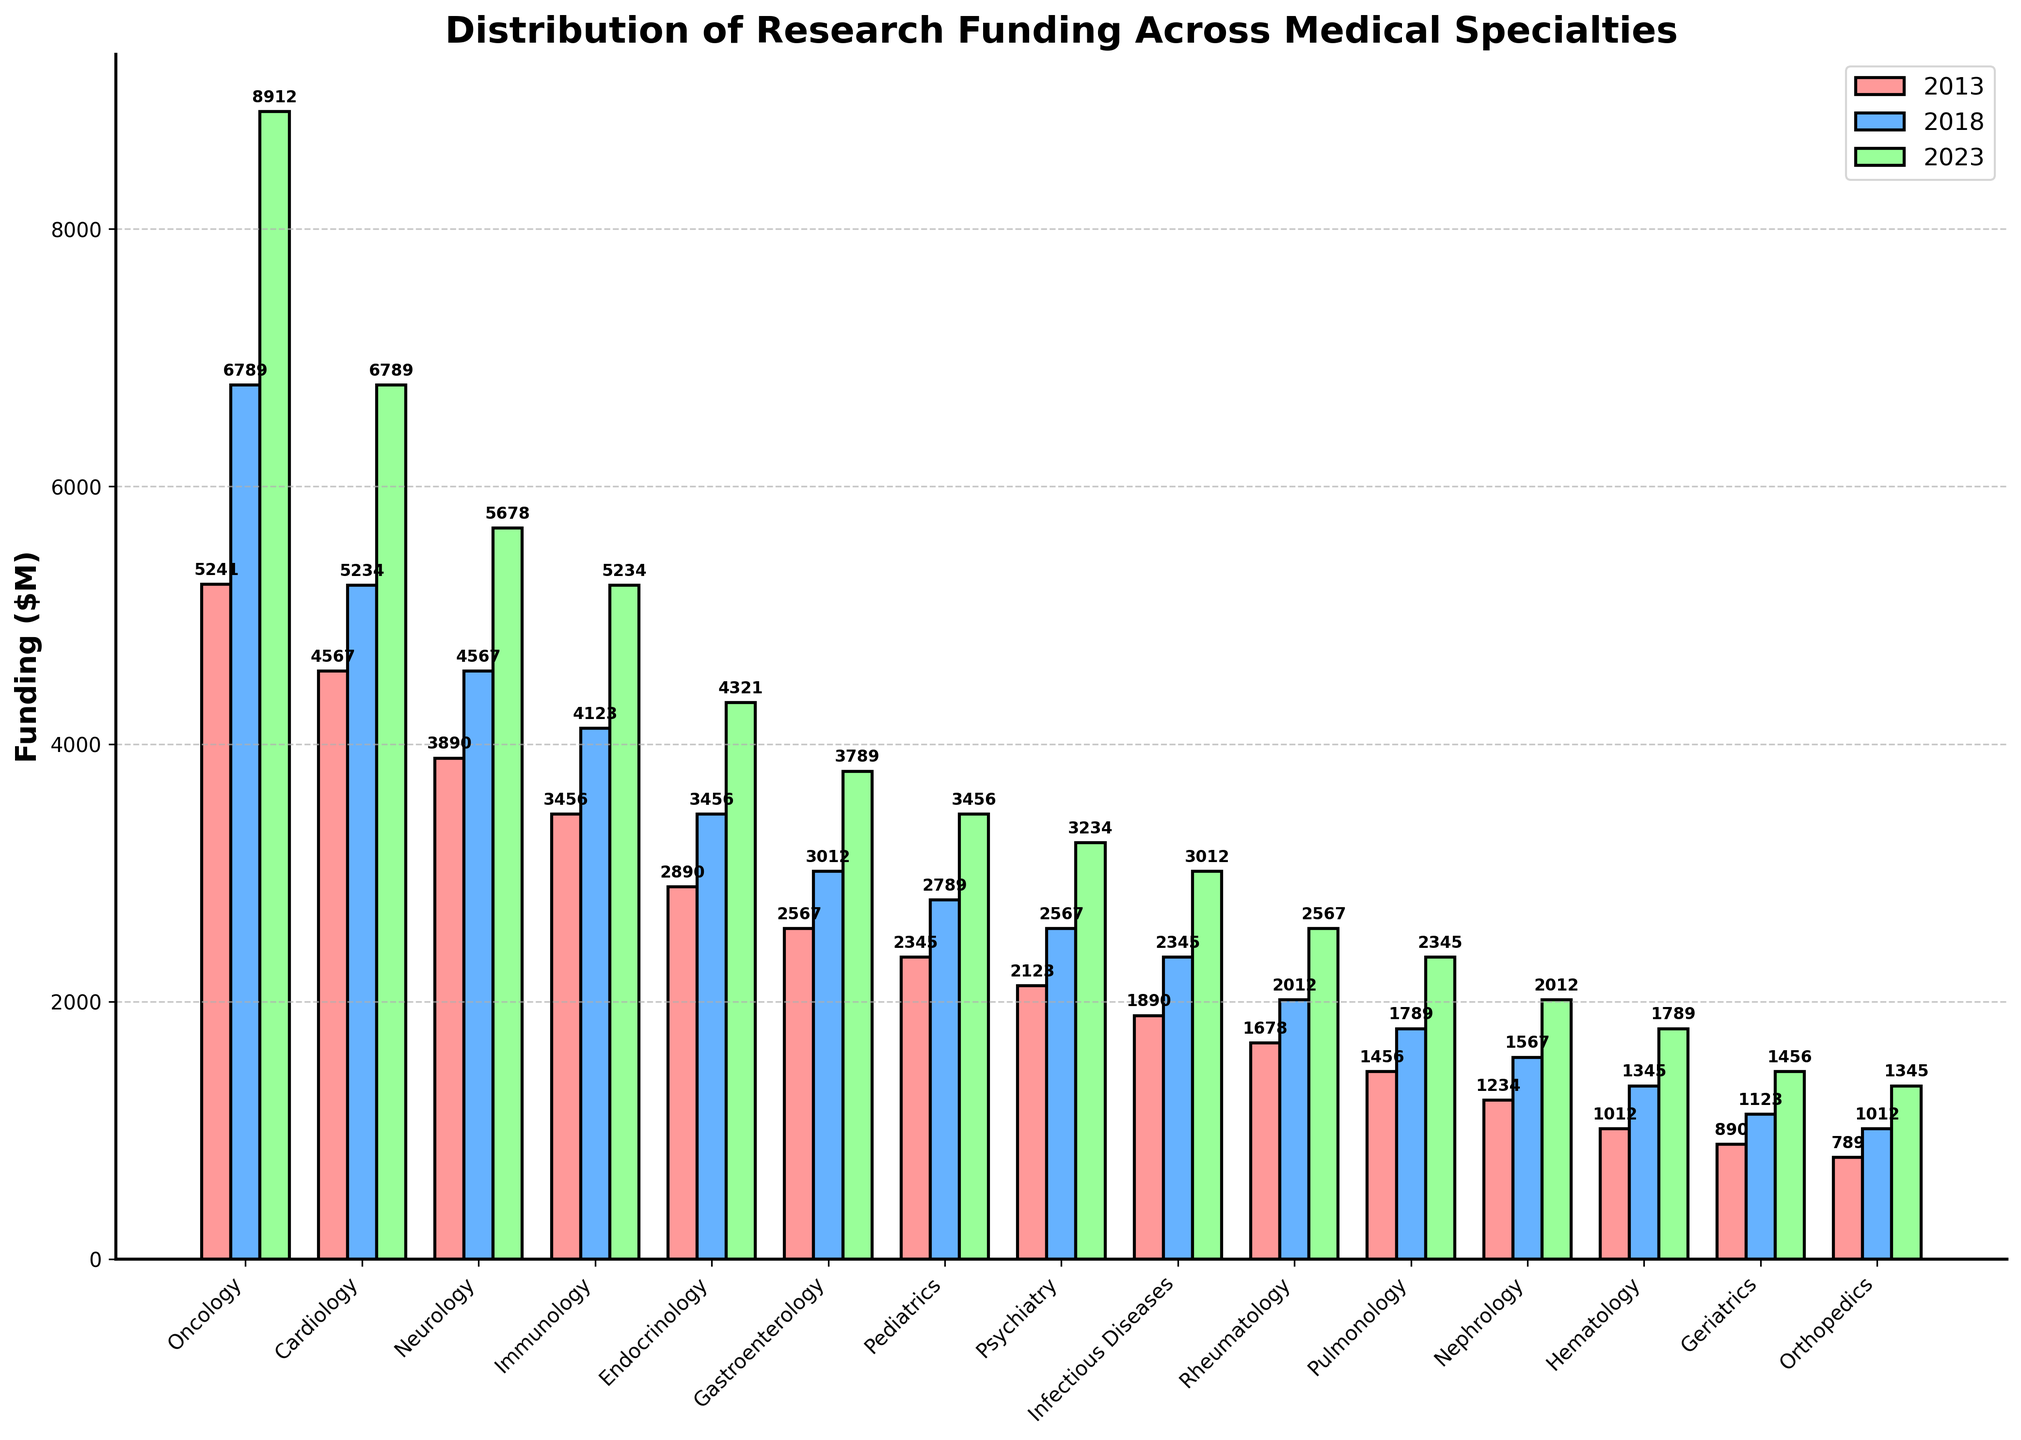What's the specialty with the highest funding in 2023? By looking at the heights of the green bars in the chart, we can see that Oncology has the highest bar for 2023.
Answer: Oncology Between 2013 and 2023, which specialty had the largest increase in funding? By calculating the difference in funding for each specialty between 2013 and 2023 and comparing these differences, Oncology shows the largest increase (8912 - 5241 = 3671).
Answer: Oncology What's the difference in funding between Immunology and Cardiology in 2023? The green bar for Immunology shows a funding of 5234 $M and for Cardiology shows 6789 $M. The difference is 6789 - 5234 = 1555 $M.
Answer: 1555 Which three specialties received the least funding in 2018? The blue bars for 2018 show Geriatrics, Orthopedics, and Hematology as the three shortest bars, indicating the least funding.
Answer: Geriatrics, Orthopedics, Hematology Which specialty showed a consistent increase in funding across all three years? By observing the bars for each specialty across the three years (red, blue, and green), Oncology consistently shows increasing heights each year, indicating a consistent increase in funding.
Answer: Oncology Compare the funding increase trends for Neurology and Psychiatry between 2013 and 2023. For Neurology, the funding increased from 3890 $M in 2013 to 5678 $M in 2023, which is an increase of 1788 $M. For Psychiatry, it increased from 2123 $M in 2013 to 3234 $M in 2023, an increase of 1111 $M. Neurology has a higher increase.
Answer: Neurology has a higher increase What is the average funding for Pediatrics over the three years shown? The funding values for Pediatrics are 2345 $M in 2013, 2789 $M in 2018, and 3456 $M in 2023. The average is calculated as (2345 + 2789 + 3456) / 3 = 2863.33 $M.
Answer: 2863.33 Which year had the highest overall funding for Endocrinology? By comparing the heights of the red, blue, and green bars for Endocrinology, the green bar is the tallest, representing 2023 with the funding of 4321 $M.
Answer: 2023 Which specialty experienced the smallest change in funding between 2013 and 2023? By calculating the differences for each specialty, Hematology shows the smallest change from 1012 $M in 2013 to 1789 $M in 2023, a difference of 777 $M.
Answer: Hematology 